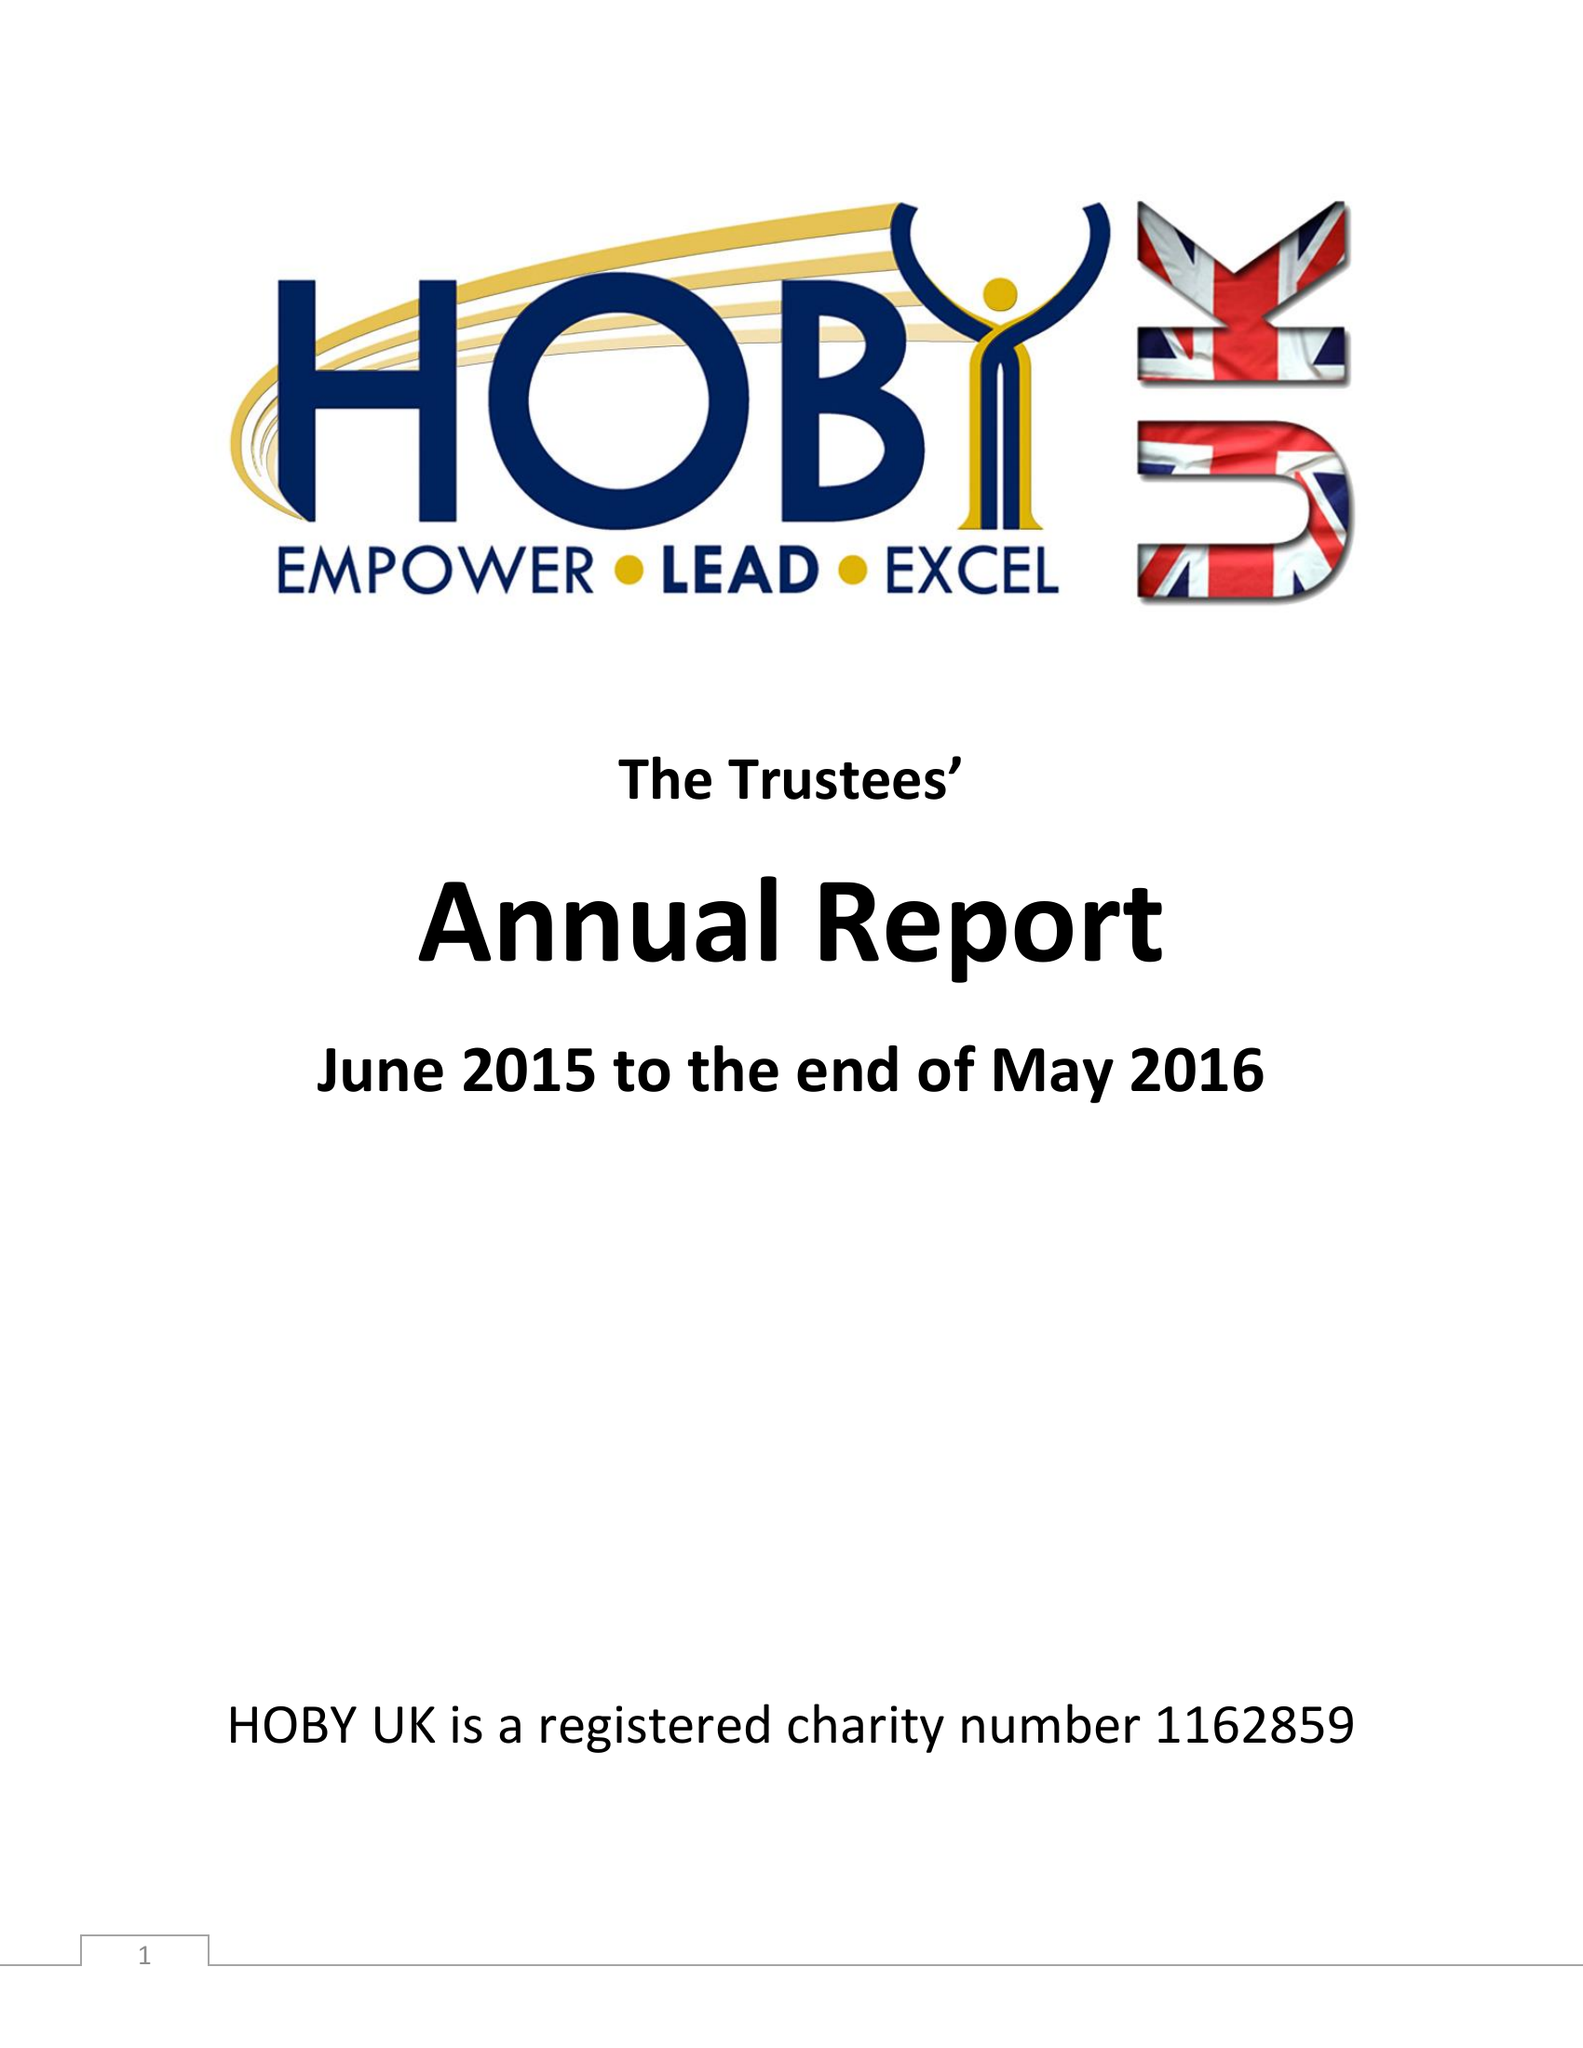What is the value for the spending_annually_in_british_pounds?
Answer the question using a single word or phrase. 14778.00 